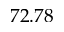<formula> <loc_0><loc_0><loc_500><loc_500>7 2 . 7 8</formula> 